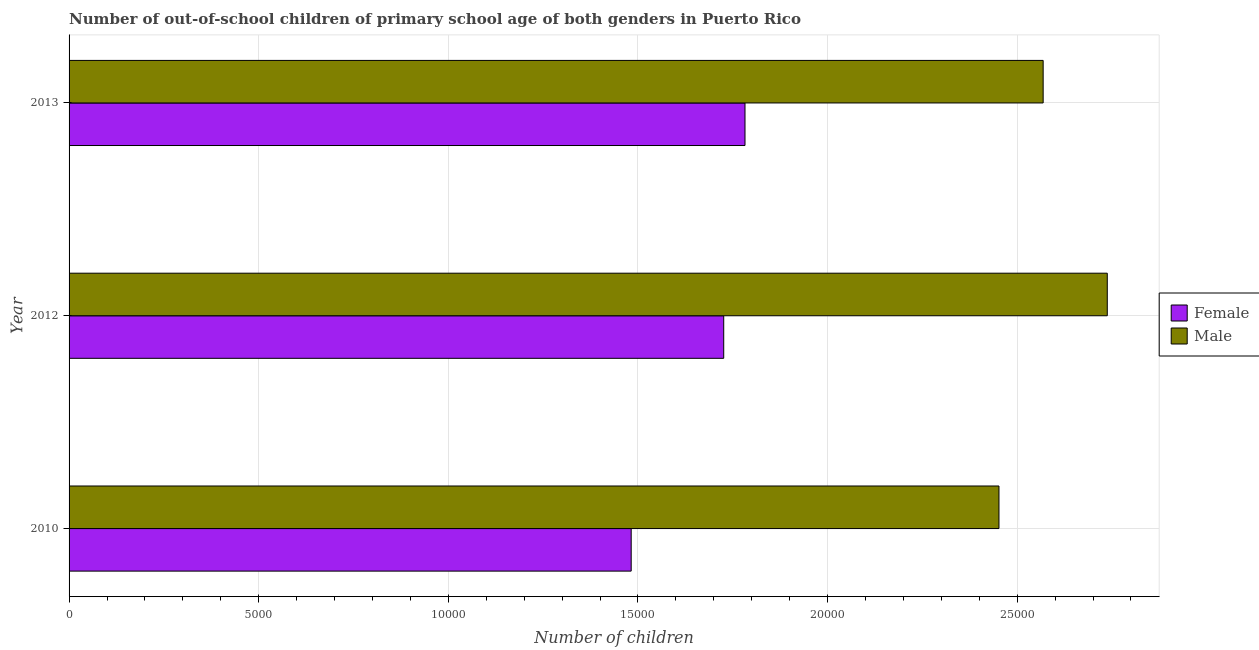How many different coloured bars are there?
Give a very brief answer. 2. Are the number of bars on each tick of the Y-axis equal?
Your answer should be very brief. Yes. How many bars are there on the 3rd tick from the bottom?
Offer a very short reply. 2. What is the label of the 2nd group of bars from the top?
Your answer should be very brief. 2012. What is the number of female out-of-school students in 2010?
Your answer should be very brief. 1.48e+04. Across all years, what is the maximum number of female out-of-school students?
Ensure brevity in your answer.  1.78e+04. Across all years, what is the minimum number of female out-of-school students?
Your answer should be very brief. 1.48e+04. In which year was the number of male out-of-school students maximum?
Your answer should be compact. 2012. What is the total number of female out-of-school students in the graph?
Keep it short and to the point. 4.99e+04. What is the difference between the number of male out-of-school students in 2012 and that in 2013?
Offer a very short reply. 1691. What is the difference between the number of male out-of-school students in 2012 and the number of female out-of-school students in 2010?
Provide a short and direct response. 1.26e+04. What is the average number of male out-of-school students per year?
Your response must be concise. 2.59e+04. In the year 2013, what is the difference between the number of male out-of-school students and number of female out-of-school students?
Ensure brevity in your answer.  7862. What is the ratio of the number of male out-of-school students in 2010 to that in 2012?
Your response must be concise. 0.9. Is the number of male out-of-school students in 2012 less than that in 2013?
Make the answer very short. No. Is the difference between the number of male out-of-school students in 2010 and 2013 greater than the difference between the number of female out-of-school students in 2010 and 2013?
Provide a short and direct response. Yes. What is the difference between the highest and the second highest number of male out-of-school students?
Ensure brevity in your answer.  1691. What is the difference between the highest and the lowest number of male out-of-school students?
Offer a very short reply. 2856. In how many years, is the number of female out-of-school students greater than the average number of female out-of-school students taken over all years?
Offer a very short reply. 2. What does the 2nd bar from the top in 2012 represents?
Your response must be concise. Female. What is the difference between two consecutive major ticks on the X-axis?
Make the answer very short. 5000. Where does the legend appear in the graph?
Your answer should be very brief. Center right. How are the legend labels stacked?
Keep it short and to the point. Vertical. What is the title of the graph?
Give a very brief answer. Number of out-of-school children of primary school age of both genders in Puerto Rico. What is the label or title of the X-axis?
Keep it short and to the point. Number of children. What is the label or title of the Y-axis?
Your response must be concise. Year. What is the Number of children of Female in 2010?
Provide a short and direct response. 1.48e+04. What is the Number of children in Male in 2010?
Offer a terse response. 2.45e+04. What is the Number of children of Female in 2012?
Provide a short and direct response. 1.73e+04. What is the Number of children of Male in 2012?
Your answer should be very brief. 2.74e+04. What is the Number of children of Female in 2013?
Your response must be concise. 1.78e+04. What is the Number of children in Male in 2013?
Offer a very short reply. 2.57e+04. Across all years, what is the maximum Number of children in Female?
Keep it short and to the point. 1.78e+04. Across all years, what is the maximum Number of children of Male?
Provide a short and direct response. 2.74e+04. Across all years, what is the minimum Number of children in Female?
Ensure brevity in your answer.  1.48e+04. Across all years, what is the minimum Number of children of Male?
Give a very brief answer. 2.45e+04. What is the total Number of children in Female in the graph?
Keep it short and to the point. 4.99e+04. What is the total Number of children in Male in the graph?
Ensure brevity in your answer.  7.76e+04. What is the difference between the Number of children of Female in 2010 and that in 2012?
Offer a terse response. -2440. What is the difference between the Number of children in Male in 2010 and that in 2012?
Offer a terse response. -2856. What is the difference between the Number of children in Female in 2010 and that in 2013?
Keep it short and to the point. -3001. What is the difference between the Number of children of Male in 2010 and that in 2013?
Ensure brevity in your answer.  -1165. What is the difference between the Number of children of Female in 2012 and that in 2013?
Provide a short and direct response. -561. What is the difference between the Number of children of Male in 2012 and that in 2013?
Ensure brevity in your answer.  1691. What is the difference between the Number of children in Female in 2010 and the Number of children in Male in 2012?
Offer a very short reply. -1.26e+04. What is the difference between the Number of children in Female in 2010 and the Number of children in Male in 2013?
Provide a short and direct response. -1.09e+04. What is the difference between the Number of children of Female in 2012 and the Number of children of Male in 2013?
Your response must be concise. -8423. What is the average Number of children of Female per year?
Provide a succinct answer. 1.66e+04. What is the average Number of children in Male per year?
Your response must be concise. 2.59e+04. In the year 2010, what is the difference between the Number of children of Female and Number of children of Male?
Give a very brief answer. -9698. In the year 2012, what is the difference between the Number of children of Female and Number of children of Male?
Provide a succinct answer. -1.01e+04. In the year 2013, what is the difference between the Number of children of Female and Number of children of Male?
Make the answer very short. -7862. What is the ratio of the Number of children in Female in 2010 to that in 2012?
Ensure brevity in your answer.  0.86. What is the ratio of the Number of children of Male in 2010 to that in 2012?
Your answer should be compact. 0.9. What is the ratio of the Number of children in Female in 2010 to that in 2013?
Provide a succinct answer. 0.83. What is the ratio of the Number of children of Male in 2010 to that in 2013?
Your response must be concise. 0.95. What is the ratio of the Number of children in Female in 2012 to that in 2013?
Your answer should be very brief. 0.97. What is the ratio of the Number of children of Male in 2012 to that in 2013?
Offer a very short reply. 1.07. What is the difference between the highest and the second highest Number of children of Female?
Offer a terse response. 561. What is the difference between the highest and the second highest Number of children in Male?
Keep it short and to the point. 1691. What is the difference between the highest and the lowest Number of children in Female?
Offer a very short reply. 3001. What is the difference between the highest and the lowest Number of children in Male?
Offer a very short reply. 2856. 